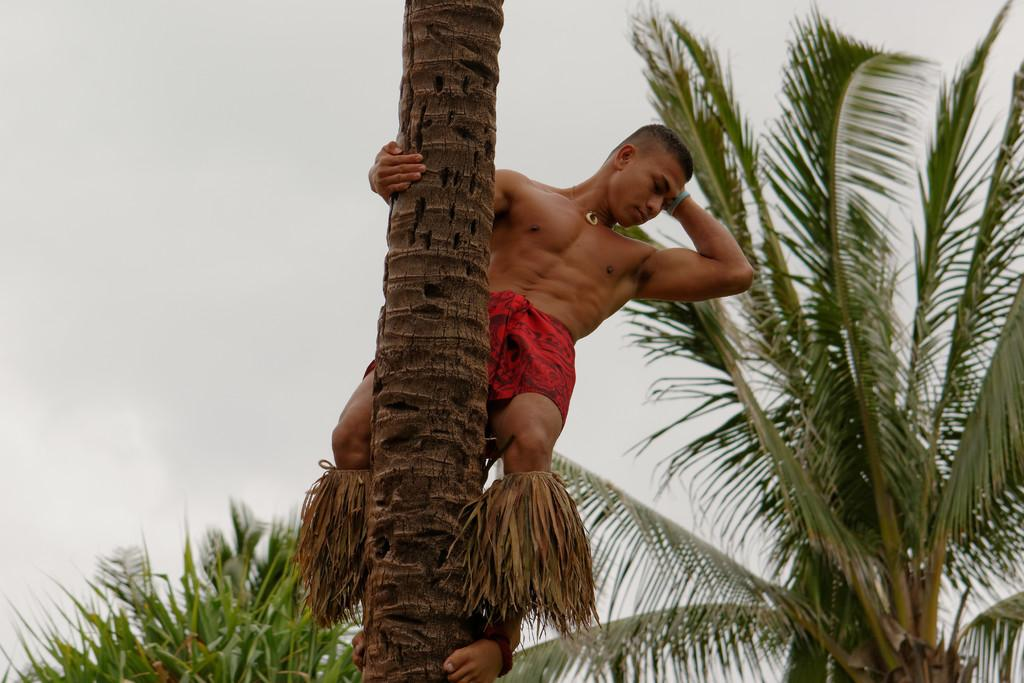What is the person in the image doing? There is a person climbing a tree in the image. What can be seen in the background of the image? There are trees and the sky visible in the background of the image. What type of print can be seen on the person's shirt in the image? There is no information about the person's shirt or any print on it in the provided facts. 